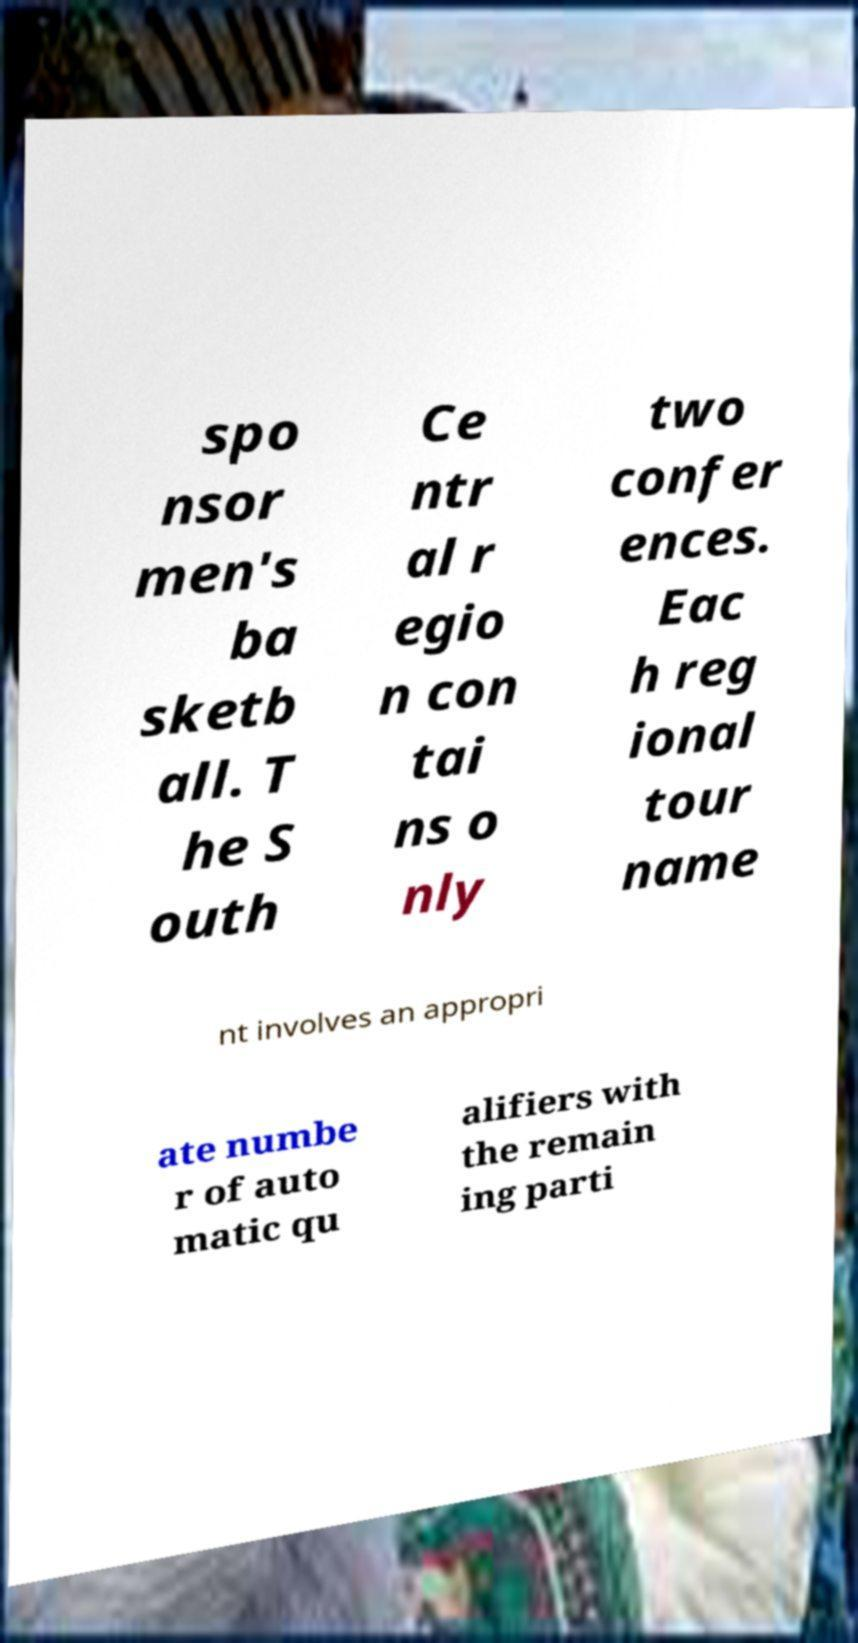Could you extract and type out the text from this image? spo nsor men's ba sketb all. T he S outh Ce ntr al r egio n con tai ns o nly two confer ences. Eac h reg ional tour name nt involves an appropri ate numbe r of auto matic qu alifiers with the remain ing parti 